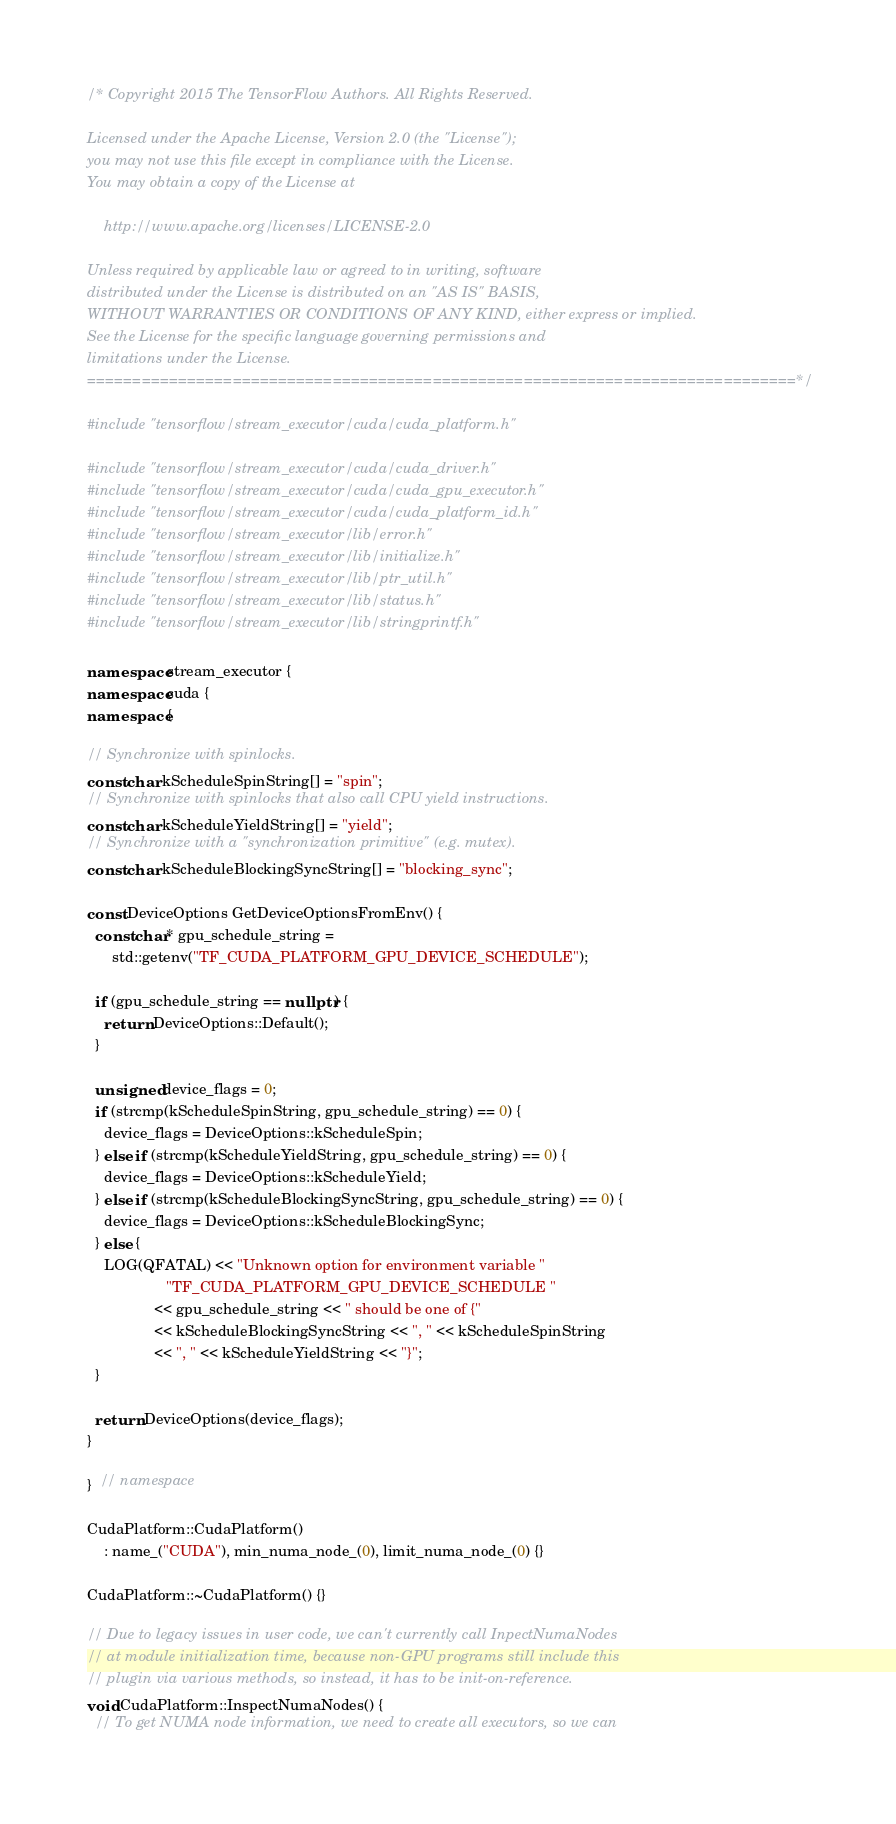<code> <loc_0><loc_0><loc_500><loc_500><_C++_>/* Copyright 2015 The TensorFlow Authors. All Rights Reserved.

Licensed under the Apache License, Version 2.0 (the "License");
you may not use this file except in compliance with the License.
You may obtain a copy of the License at

    http://www.apache.org/licenses/LICENSE-2.0

Unless required by applicable law or agreed to in writing, software
distributed under the License is distributed on an "AS IS" BASIS,
WITHOUT WARRANTIES OR CONDITIONS OF ANY KIND, either express or implied.
See the License for the specific language governing permissions and
limitations under the License.
==============================================================================*/

#include "tensorflow/stream_executor/cuda/cuda_platform.h"

#include "tensorflow/stream_executor/cuda/cuda_driver.h"
#include "tensorflow/stream_executor/cuda/cuda_gpu_executor.h"
#include "tensorflow/stream_executor/cuda/cuda_platform_id.h"
#include "tensorflow/stream_executor/lib/error.h"
#include "tensorflow/stream_executor/lib/initialize.h"
#include "tensorflow/stream_executor/lib/ptr_util.h"
#include "tensorflow/stream_executor/lib/status.h"
#include "tensorflow/stream_executor/lib/stringprintf.h"

namespace stream_executor {
namespace cuda {
namespace {

// Synchronize with spinlocks.
const char kScheduleSpinString[] = "spin";
// Synchronize with spinlocks that also call CPU yield instructions.
const char kScheduleYieldString[] = "yield";
// Synchronize with a "synchronization primitive" (e.g. mutex).
const char kScheduleBlockingSyncString[] = "blocking_sync";

const DeviceOptions GetDeviceOptionsFromEnv() {
  const char* gpu_schedule_string =
      std::getenv("TF_CUDA_PLATFORM_GPU_DEVICE_SCHEDULE");

  if (gpu_schedule_string == nullptr) {
    return DeviceOptions::Default();
  }

  unsigned device_flags = 0;
  if (strcmp(kScheduleSpinString, gpu_schedule_string) == 0) {
    device_flags = DeviceOptions::kScheduleSpin;
  } else if (strcmp(kScheduleYieldString, gpu_schedule_string) == 0) {
    device_flags = DeviceOptions::kScheduleYield;
  } else if (strcmp(kScheduleBlockingSyncString, gpu_schedule_string) == 0) {
    device_flags = DeviceOptions::kScheduleBlockingSync;
  } else {
    LOG(QFATAL) << "Unknown option for environment variable "
                   "TF_CUDA_PLATFORM_GPU_DEVICE_SCHEDULE "
                << gpu_schedule_string << " should be one of {"
                << kScheduleBlockingSyncString << ", " << kScheduleSpinString
                << ", " << kScheduleYieldString << "}";
  }

  return DeviceOptions(device_flags);
}

}  // namespace

CudaPlatform::CudaPlatform()
    : name_("CUDA"), min_numa_node_(0), limit_numa_node_(0) {}

CudaPlatform::~CudaPlatform() {}

// Due to legacy issues in user code, we can't currently call InpectNumaNodes
// at module initialization time, because non-GPU programs still include this
// plugin via various methods, so instead, it has to be init-on-reference.
void CudaPlatform::InspectNumaNodes() {
  // To get NUMA node information, we need to create all executors, so we can</code> 